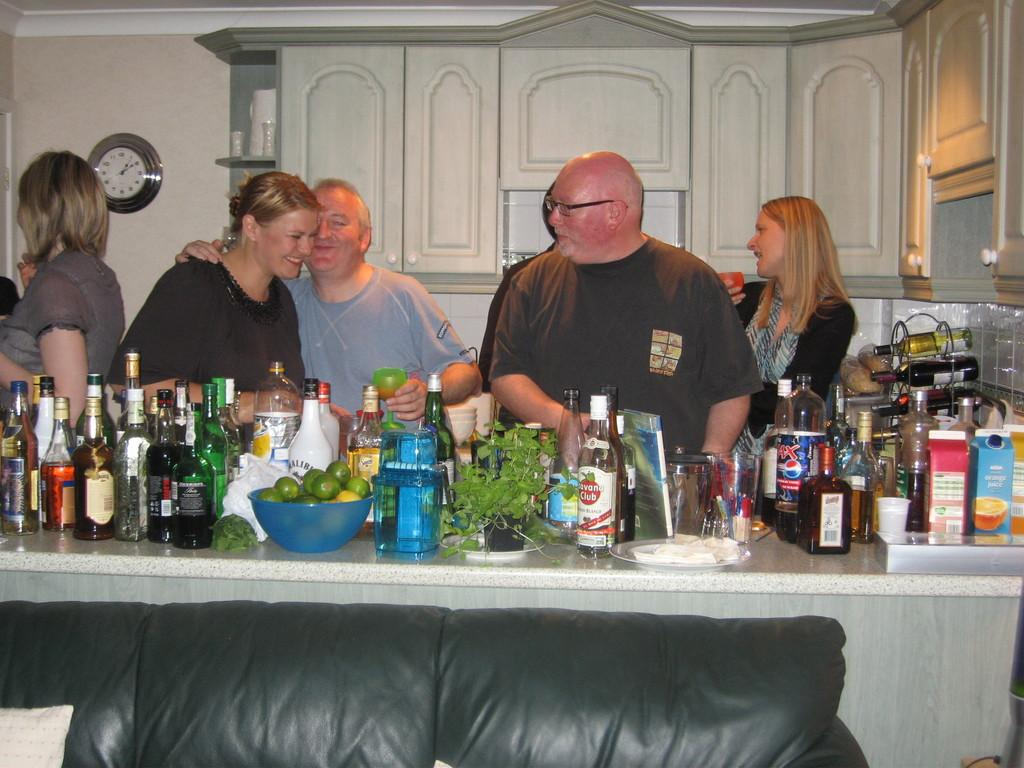<image>
Relay a brief, clear account of the picture shown. Bottle of Havana Club on a counter in front of a group of people. 